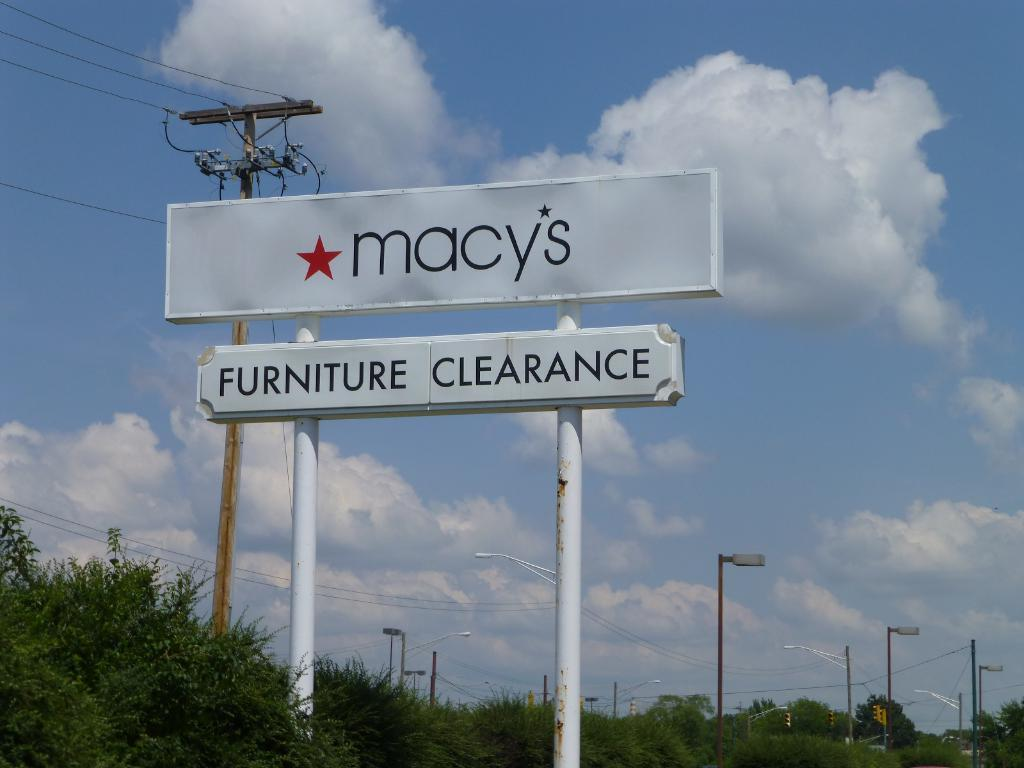<image>
Write a terse but informative summary of the picture. A weathered store sign for Macy's store stands tall in front of a blue sky. 